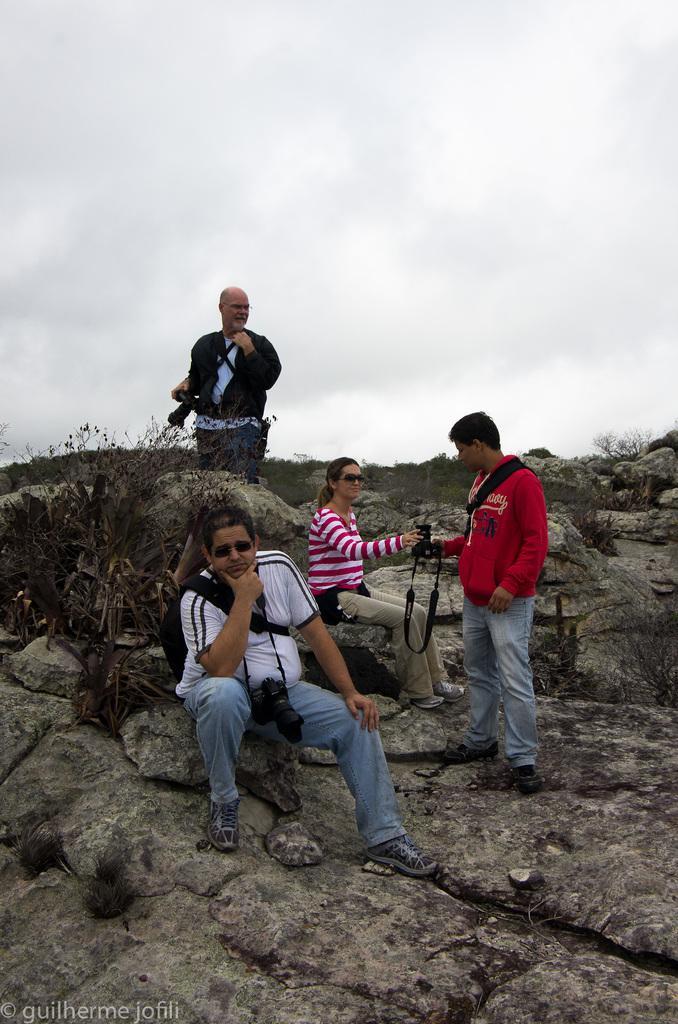Please provide a concise description of this image. In this image, we can see persons on the hill. There are plants on the left side of the image. There is a sky at the top of the image. 